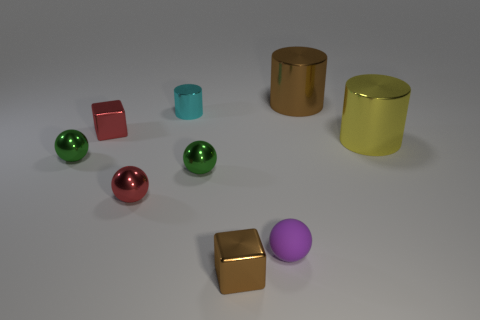There is a matte thing; is it the same color as the thing that is in front of the small purple object?
Ensure brevity in your answer.  No. The matte sphere has what color?
Offer a terse response. Purple. There is a big object on the left side of the large thing that is to the right of the brown thing that is to the right of the purple sphere; what is its shape?
Provide a succinct answer. Cylinder. How many other objects are there of the same color as the tiny cylinder?
Provide a succinct answer. 0. Are there more big metallic objects that are to the left of the tiny brown thing than tiny purple matte objects that are to the right of the rubber thing?
Give a very brief answer. No. There is a tiny purple thing; are there any red shiny objects on the left side of it?
Keep it short and to the point. Yes. There is a thing that is both in front of the red ball and on the left side of the small purple matte object; what is its material?
Give a very brief answer. Metal. What color is the other small object that is the same shape as the yellow shiny thing?
Ensure brevity in your answer.  Cyan. Are there any small balls that are behind the small object that is on the right side of the brown metallic block?
Offer a terse response. Yes. What size is the purple rubber thing?
Make the answer very short. Small. 